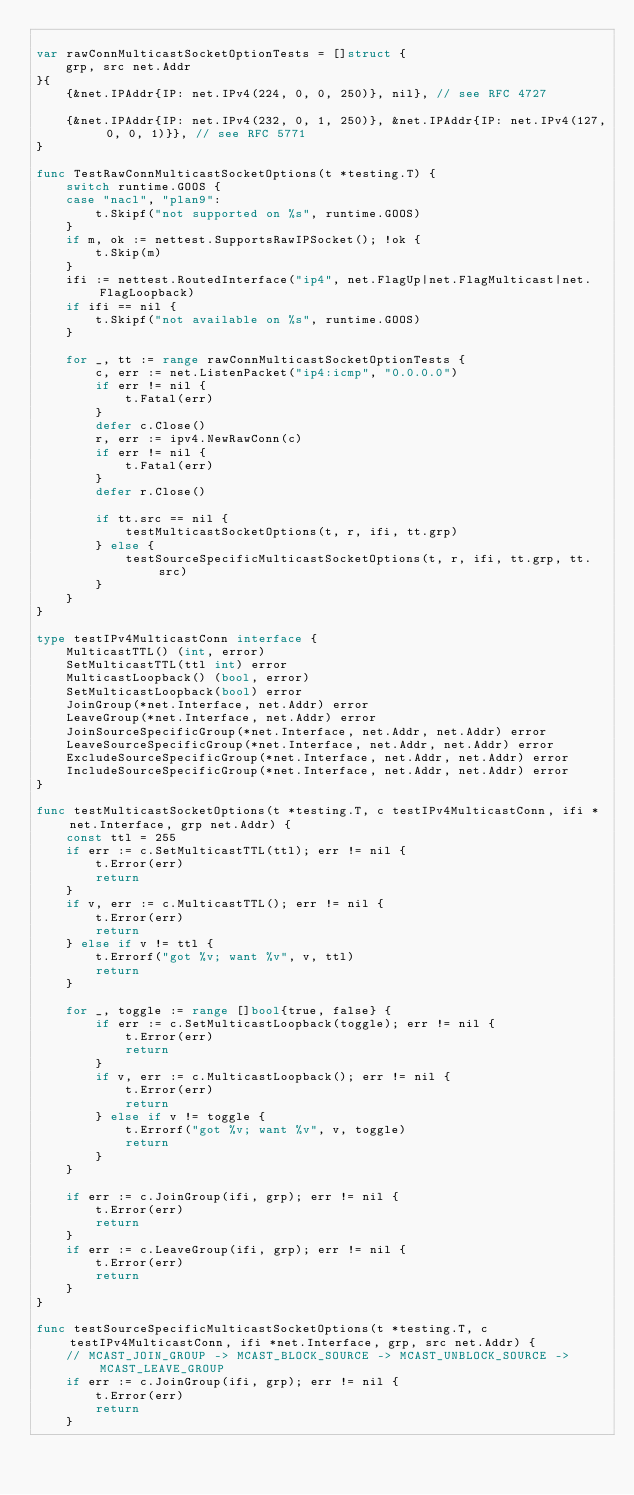<code> <loc_0><loc_0><loc_500><loc_500><_Go_>
var rawConnMulticastSocketOptionTests = []struct {
	grp, src net.Addr
}{
	{&net.IPAddr{IP: net.IPv4(224, 0, 0, 250)}, nil}, // see RFC 4727

	{&net.IPAddr{IP: net.IPv4(232, 0, 1, 250)}, &net.IPAddr{IP: net.IPv4(127, 0, 0, 1)}}, // see RFC 5771
}

func TestRawConnMulticastSocketOptions(t *testing.T) {
	switch runtime.GOOS {
	case "nacl", "plan9":
		t.Skipf("not supported on %s", runtime.GOOS)
	}
	if m, ok := nettest.SupportsRawIPSocket(); !ok {
		t.Skip(m)
	}
	ifi := nettest.RoutedInterface("ip4", net.FlagUp|net.FlagMulticast|net.FlagLoopback)
	if ifi == nil {
		t.Skipf("not available on %s", runtime.GOOS)
	}

	for _, tt := range rawConnMulticastSocketOptionTests {
		c, err := net.ListenPacket("ip4:icmp", "0.0.0.0")
		if err != nil {
			t.Fatal(err)
		}
		defer c.Close()
		r, err := ipv4.NewRawConn(c)
		if err != nil {
			t.Fatal(err)
		}
		defer r.Close()

		if tt.src == nil {
			testMulticastSocketOptions(t, r, ifi, tt.grp)
		} else {
			testSourceSpecificMulticastSocketOptions(t, r, ifi, tt.grp, tt.src)
		}
	}
}

type testIPv4MulticastConn interface {
	MulticastTTL() (int, error)
	SetMulticastTTL(ttl int) error
	MulticastLoopback() (bool, error)
	SetMulticastLoopback(bool) error
	JoinGroup(*net.Interface, net.Addr) error
	LeaveGroup(*net.Interface, net.Addr) error
	JoinSourceSpecificGroup(*net.Interface, net.Addr, net.Addr) error
	LeaveSourceSpecificGroup(*net.Interface, net.Addr, net.Addr) error
	ExcludeSourceSpecificGroup(*net.Interface, net.Addr, net.Addr) error
	IncludeSourceSpecificGroup(*net.Interface, net.Addr, net.Addr) error
}

func testMulticastSocketOptions(t *testing.T, c testIPv4MulticastConn, ifi *net.Interface, grp net.Addr) {
	const ttl = 255
	if err := c.SetMulticastTTL(ttl); err != nil {
		t.Error(err)
		return
	}
	if v, err := c.MulticastTTL(); err != nil {
		t.Error(err)
		return
	} else if v != ttl {
		t.Errorf("got %v; want %v", v, ttl)
		return
	}

	for _, toggle := range []bool{true, false} {
		if err := c.SetMulticastLoopback(toggle); err != nil {
			t.Error(err)
			return
		}
		if v, err := c.MulticastLoopback(); err != nil {
			t.Error(err)
			return
		} else if v != toggle {
			t.Errorf("got %v; want %v", v, toggle)
			return
		}
	}

	if err := c.JoinGroup(ifi, grp); err != nil {
		t.Error(err)
		return
	}
	if err := c.LeaveGroup(ifi, grp); err != nil {
		t.Error(err)
		return
	}
}

func testSourceSpecificMulticastSocketOptions(t *testing.T, c testIPv4MulticastConn, ifi *net.Interface, grp, src net.Addr) {
	// MCAST_JOIN_GROUP -> MCAST_BLOCK_SOURCE -> MCAST_UNBLOCK_SOURCE -> MCAST_LEAVE_GROUP
	if err := c.JoinGroup(ifi, grp); err != nil {
		t.Error(err)
		return
	}</code> 